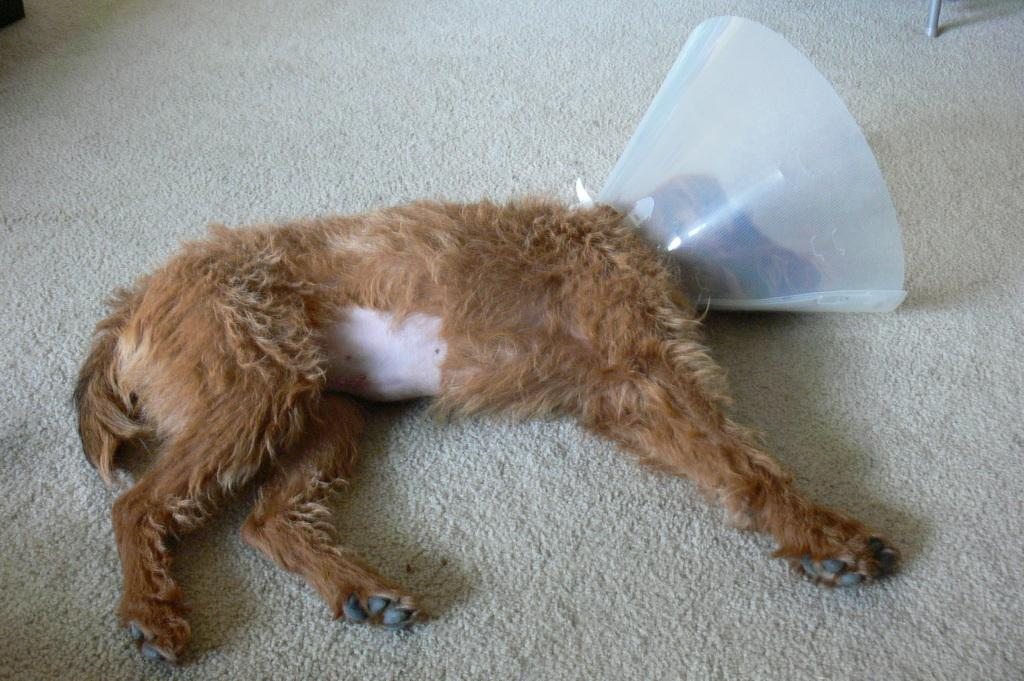What animal can be seen in the image? There is a dog in the image. What is the dog doing in the image? The dog is sleeping on the floor carpet. What is located near the dog's head? There is an object near the dog's head. What can be seen in the background of the image? The background of the image contains objects. What type of toy is the dog playing with in the image? There is no toy present in the image, and the dog is sleeping rather than playing. 